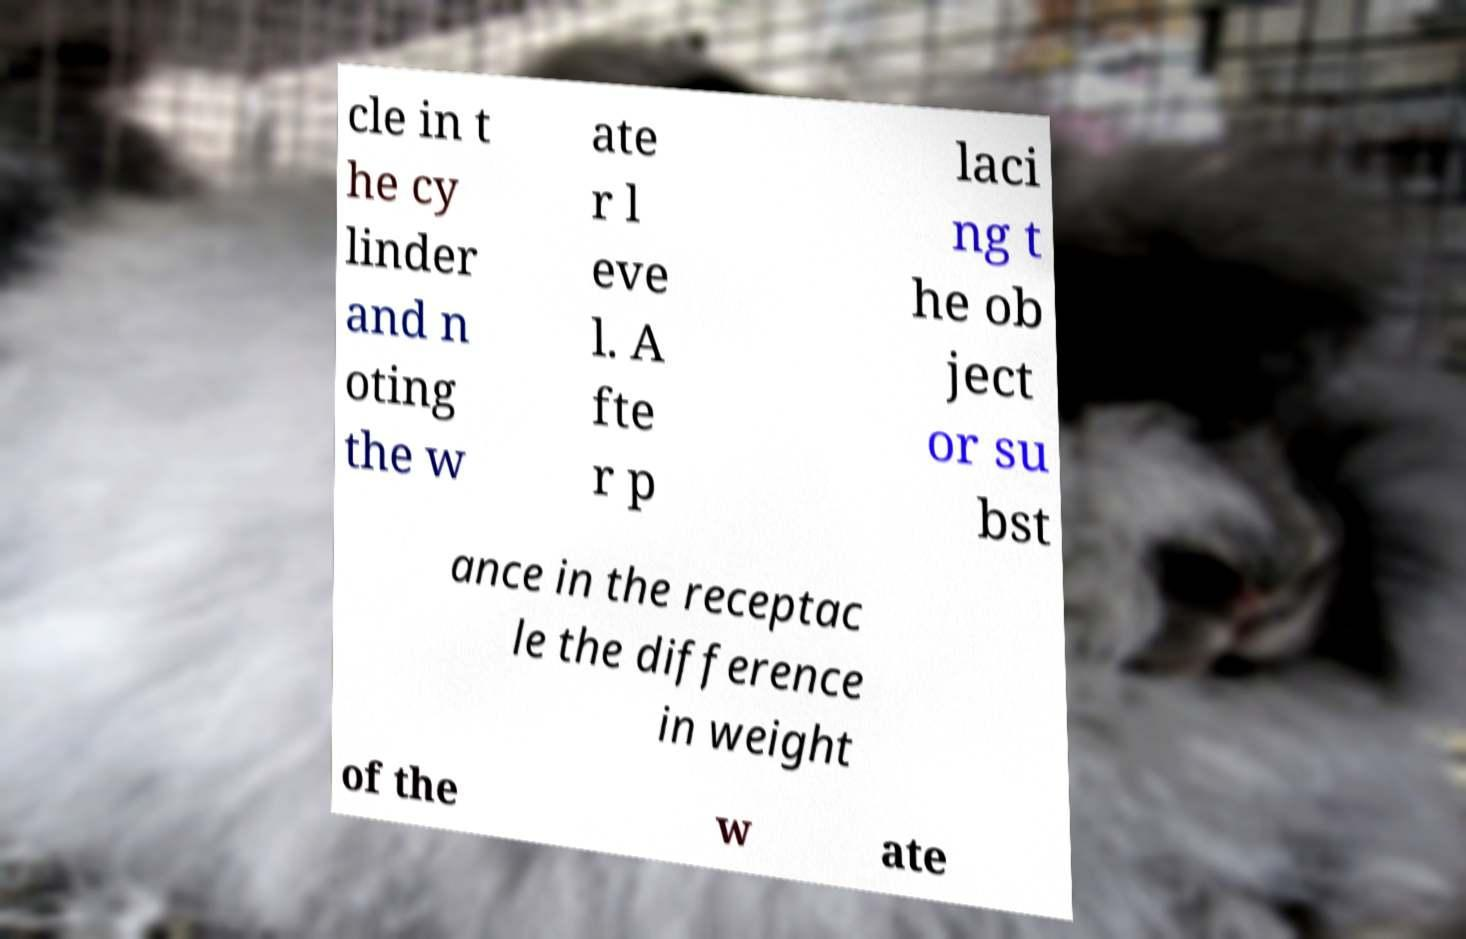There's text embedded in this image that I need extracted. Can you transcribe it verbatim? cle in t he cy linder and n oting the w ate r l eve l. A fte r p laci ng t he ob ject or su bst ance in the receptac le the difference in weight of the w ate 